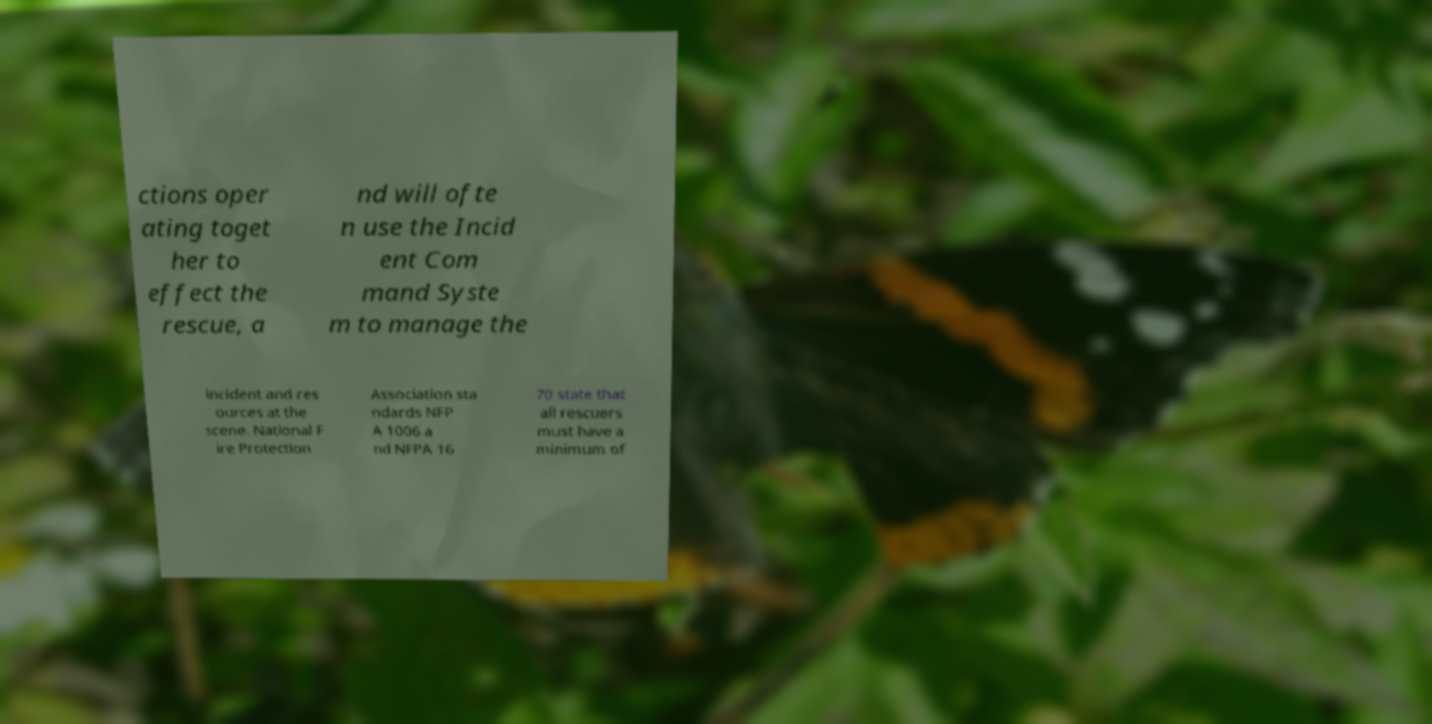Can you accurately transcribe the text from the provided image for me? ctions oper ating toget her to effect the rescue, a nd will ofte n use the Incid ent Com mand Syste m to manage the incident and res ources at the scene. National F ire Protection Association sta ndards NFP A 1006 a nd NFPA 16 70 state that all rescuers must have a minimum of 